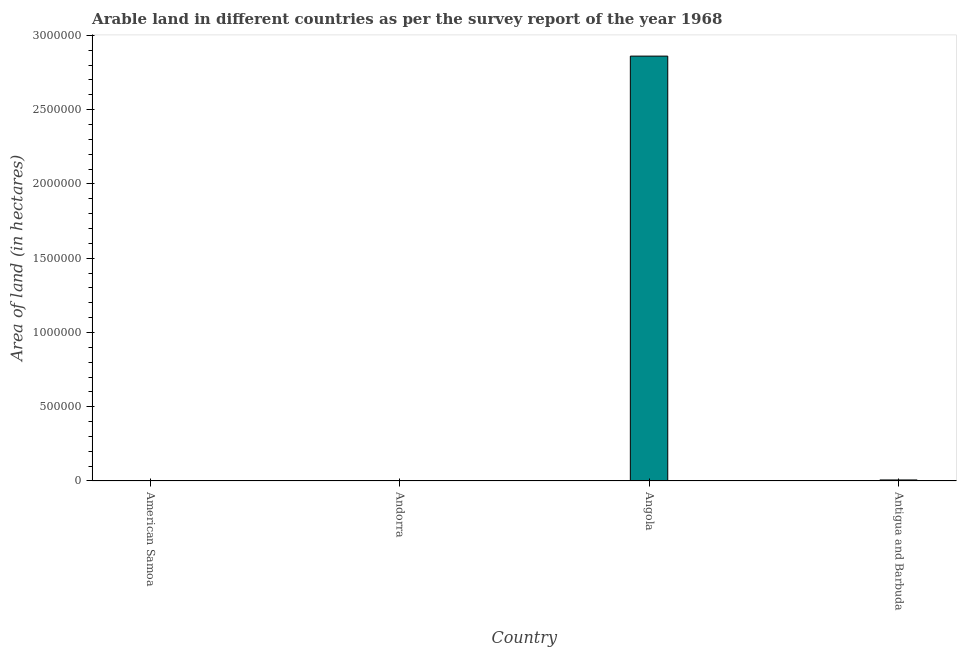Does the graph contain any zero values?
Give a very brief answer. No. What is the title of the graph?
Ensure brevity in your answer.  Arable land in different countries as per the survey report of the year 1968. What is the label or title of the X-axis?
Provide a short and direct response. Country. What is the label or title of the Y-axis?
Ensure brevity in your answer.  Area of land (in hectares). What is the area of land in American Samoa?
Provide a short and direct response. 1000. Across all countries, what is the maximum area of land?
Give a very brief answer. 2.86e+06. In which country was the area of land maximum?
Make the answer very short. Angola. In which country was the area of land minimum?
Your response must be concise. American Samoa. What is the sum of the area of land?
Your answer should be very brief. 2.87e+06. What is the difference between the area of land in Andorra and Antigua and Barbuda?
Make the answer very short. -6000. What is the average area of land per country?
Your answer should be very brief. 7.17e+05. What is the median area of land?
Provide a short and direct response. 4000. What is the difference between the highest and the second highest area of land?
Your answer should be compact. 2.85e+06. Is the sum of the area of land in American Samoa and Angola greater than the maximum area of land across all countries?
Your answer should be compact. Yes. What is the difference between the highest and the lowest area of land?
Make the answer very short. 2.86e+06. In how many countries, is the area of land greater than the average area of land taken over all countries?
Offer a very short reply. 1. How many bars are there?
Provide a succinct answer. 4. Are all the bars in the graph horizontal?
Ensure brevity in your answer.  No. Are the values on the major ticks of Y-axis written in scientific E-notation?
Offer a terse response. No. What is the Area of land (in hectares) of American Samoa?
Make the answer very short. 1000. What is the Area of land (in hectares) of Andorra?
Provide a short and direct response. 1000. What is the Area of land (in hectares) of Angola?
Keep it short and to the point. 2.86e+06. What is the Area of land (in hectares) in Antigua and Barbuda?
Provide a short and direct response. 7000. What is the difference between the Area of land (in hectares) in American Samoa and Andorra?
Provide a short and direct response. 0. What is the difference between the Area of land (in hectares) in American Samoa and Angola?
Offer a very short reply. -2.86e+06. What is the difference between the Area of land (in hectares) in American Samoa and Antigua and Barbuda?
Offer a very short reply. -6000. What is the difference between the Area of land (in hectares) in Andorra and Angola?
Offer a very short reply. -2.86e+06. What is the difference between the Area of land (in hectares) in Andorra and Antigua and Barbuda?
Provide a succinct answer. -6000. What is the difference between the Area of land (in hectares) in Angola and Antigua and Barbuda?
Keep it short and to the point. 2.85e+06. What is the ratio of the Area of land (in hectares) in American Samoa to that in Antigua and Barbuda?
Give a very brief answer. 0.14. What is the ratio of the Area of land (in hectares) in Andorra to that in Angola?
Keep it short and to the point. 0. What is the ratio of the Area of land (in hectares) in Andorra to that in Antigua and Barbuda?
Offer a terse response. 0.14. What is the ratio of the Area of land (in hectares) in Angola to that in Antigua and Barbuda?
Offer a terse response. 408.57. 